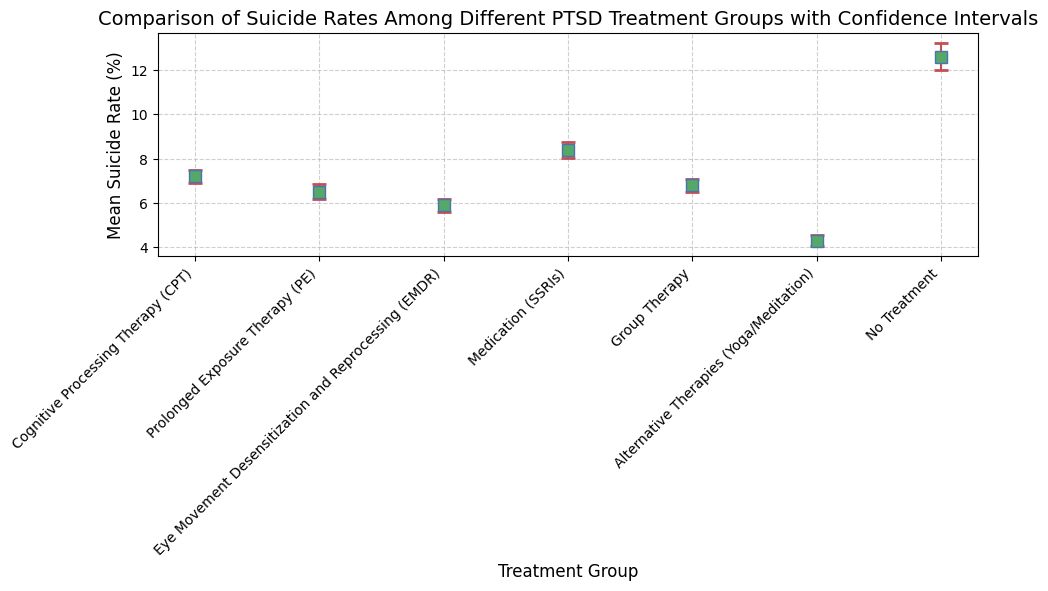Which treatment group has the lowest mean suicide rate? Among the treatment groups, Alternative Therapies (Yoga/Meditation) have the lowest mean suicide rate of 4.3%.
Answer: Alternative Therapies (Yoga/Meditation) Which treatment group has the highest mean suicide rate? By examining the figures, No Treatment has the highest mean suicide rate of 12.6%.
Answer: No Treatment What is the difference in mean suicide rates between the group with the highest and the group with the lowest mean suicide rates? The highest mean suicide rate is 12.6% (No Treatment) and the lowest is 4.3% (Alternative Therapies (Yoga/Meditation)). Thus, the difference is 12.6% - 4.3% = 8.3%.
Answer: 8.3% Which treatment groups' mean suicide rates fall within one standard deviation of the mean rate across all groups? First, calculate the mean rate across all groups: (7.2 + 6.5 + 5.9 + 8.4 + 6.8 + 4.3 + 12.6)/7 = 7.3857. Then calculate the standard deviation of these rates. After that, find the groups whose rates fall within the interval [mean − stddev, mean + stddev].
Answer: Detailed calculation required What is the average mean suicide rate across all treatment groups excluding "No Treatment"? Excluding "No Treatment", the mean suicide rates are: 7.2, 6.5, 5.9, 8.4, 6.8, 4.3. The average is (7.2 + 6.5 + 5.9 + 8.4 + 6.8 + 4.3)/6 = 6.85%.
Answer: 6.85% Which group has the widest confidence interval? The confidence interval width is 2 times the standard error. Since the No Treatment group has the highest standard deviation (2.2%) and the smallest sample size (50), it will have the widest confidence interval.
Answer: No Treatment Is the mean suicide rate for "Cognitive Processing Therapy (CPT)" statistically significantly different from "Medication (SSRIs)"? (Assume significance means non-overlapping confidence intervals) The mean suicide rate for CPT is 7.2% with a CI of ±0.294%. For SSRIs, it’s 8.4% with a CI of ±0.353%. Because the intervals 6.906% − 7.494% and 8.047% − 8.753% do not overlap, CPT is statistically significantly different from SSRIs.
Answer: Yes Which treatment group has the green-colored markers in the figure? The markers for the Alternative Therapies (Yoga/Meditation) group are green.
Answer: Alternative Therapies (Yoga/Meditation) Out of the therapy options (CPT, PE, EMDR, Group Therapy), which has the highest mean suicide rate? Among the therapies, CPT has the highest mean suicide rate at 7.2%.
Answer: CPT 